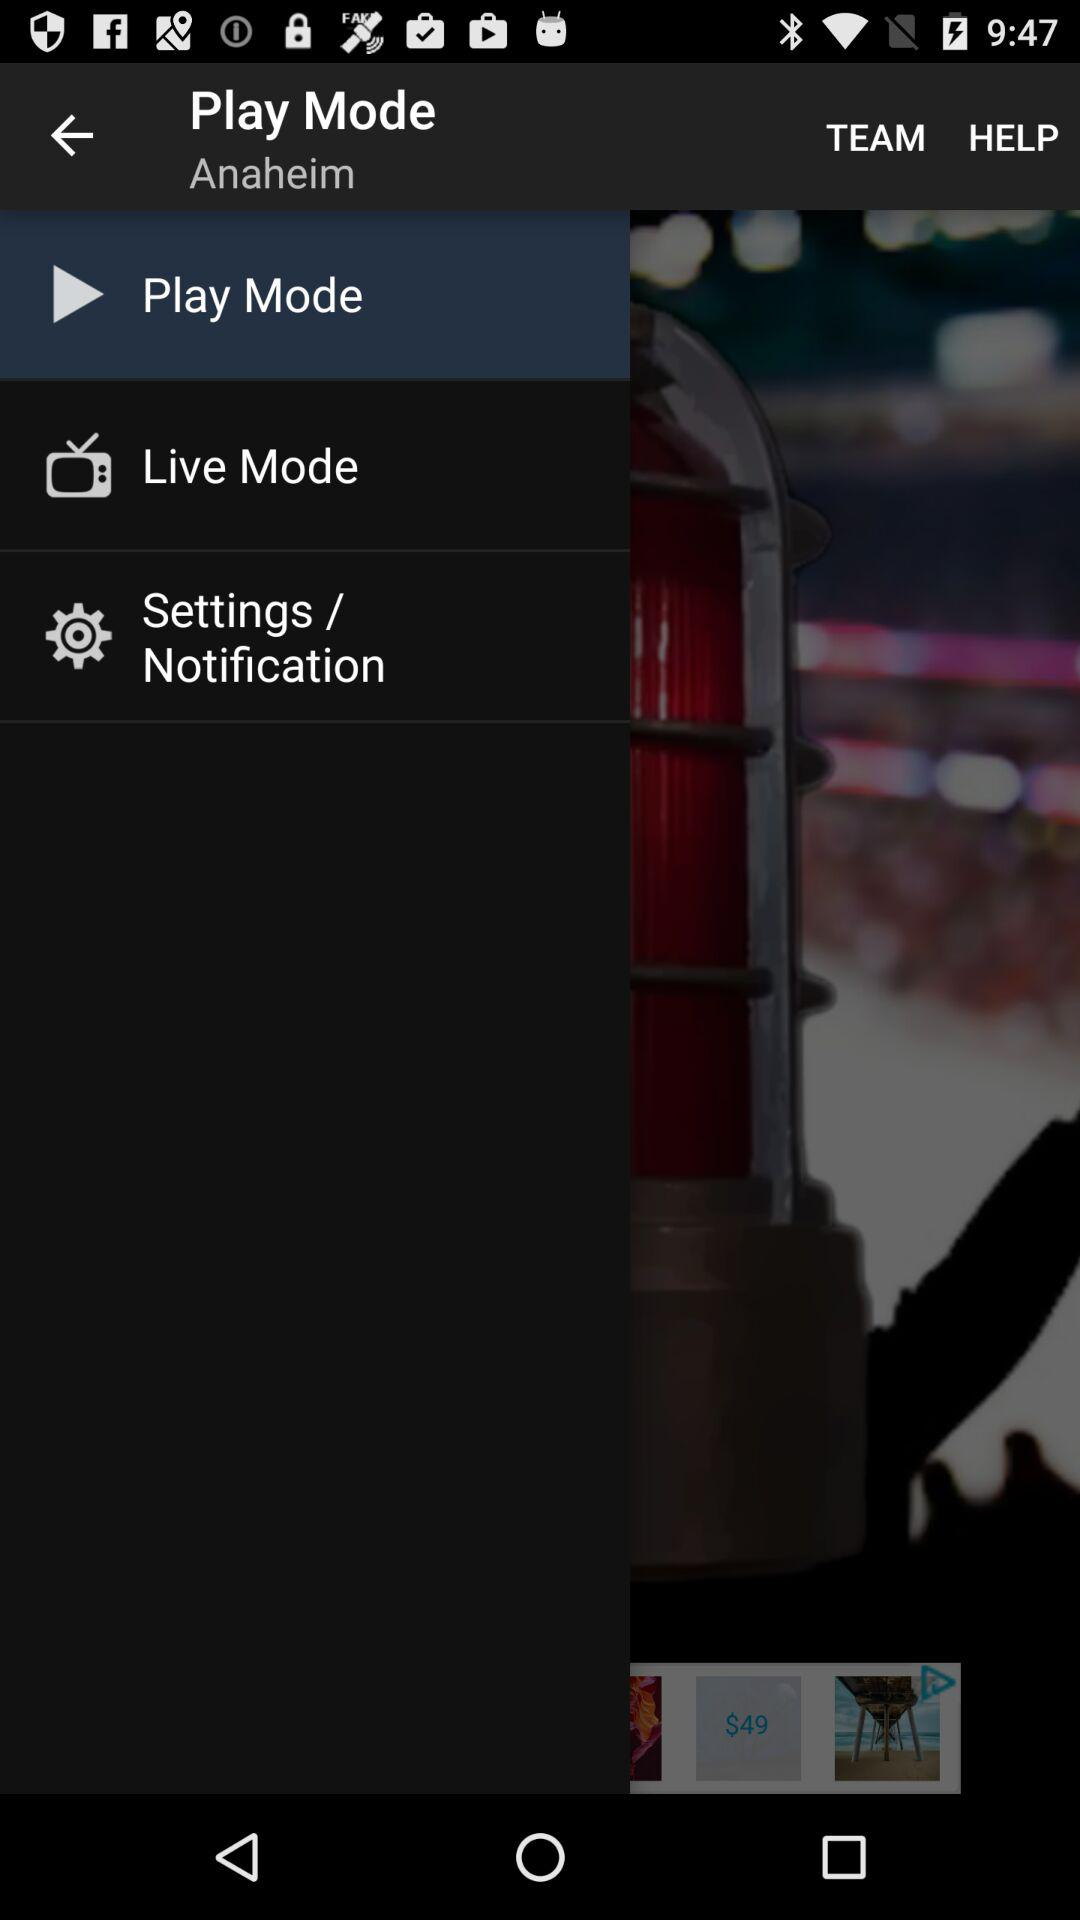Which item is selected in the menu? The item "Play Mode" is selected in the menu. 